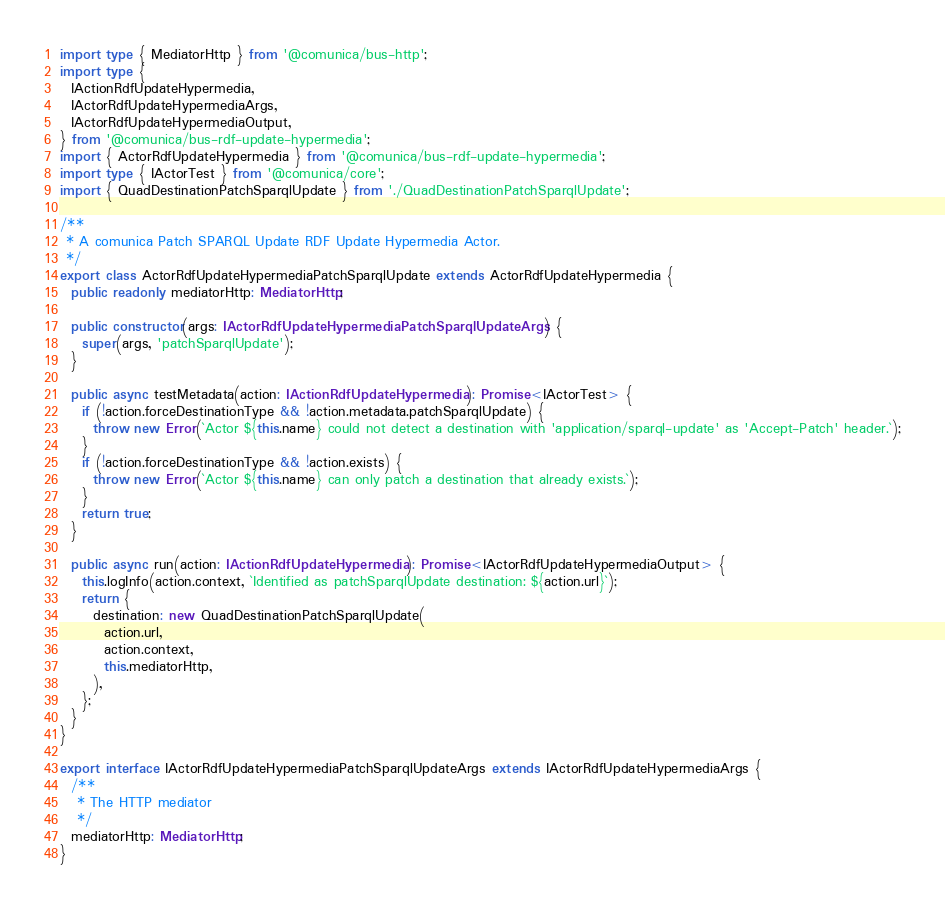<code> <loc_0><loc_0><loc_500><loc_500><_TypeScript_>import type { MediatorHttp } from '@comunica/bus-http';
import type {
  IActionRdfUpdateHypermedia,
  IActorRdfUpdateHypermediaArgs,
  IActorRdfUpdateHypermediaOutput,
} from '@comunica/bus-rdf-update-hypermedia';
import { ActorRdfUpdateHypermedia } from '@comunica/bus-rdf-update-hypermedia';
import type { IActorTest } from '@comunica/core';
import { QuadDestinationPatchSparqlUpdate } from './QuadDestinationPatchSparqlUpdate';

/**
 * A comunica Patch SPARQL Update RDF Update Hypermedia Actor.
 */
export class ActorRdfUpdateHypermediaPatchSparqlUpdate extends ActorRdfUpdateHypermedia {
  public readonly mediatorHttp: MediatorHttp;

  public constructor(args: IActorRdfUpdateHypermediaPatchSparqlUpdateArgs) {
    super(args, 'patchSparqlUpdate');
  }

  public async testMetadata(action: IActionRdfUpdateHypermedia): Promise<IActorTest> {
    if (!action.forceDestinationType && !action.metadata.patchSparqlUpdate) {
      throw new Error(`Actor ${this.name} could not detect a destination with 'application/sparql-update' as 'Accept-Patch' header.`);
    }
    if (!action.forceDestinationType && !action.exists) {
      throw new Error(`Actor ${this.name} can only patch a destination that already exists.`);
    }
    return true;
  }

  public async run(action: IActionRdfUpdateHypermedia): Promise<IActorRdfUpdateHypermediaOutput> {
    this.logInfo(action.context, `Identified as patchSparqlUpdate destination: ${action.url}`);
    return {
      destination: new QuadDestinationPatchSparqlUpdate(
        action.url,
        action.context,
        this.mediatorHttp,
      ),
    };
  }
}

export interface IActorRdfUpdateHypermediaPatchSparqlUpdateArgs extends IActorRdfUpdateHypermediaArgs {
  /**
   * The HTTP mediator
   */
  mediatorHttp: MediatorHttp;
}
</code> 